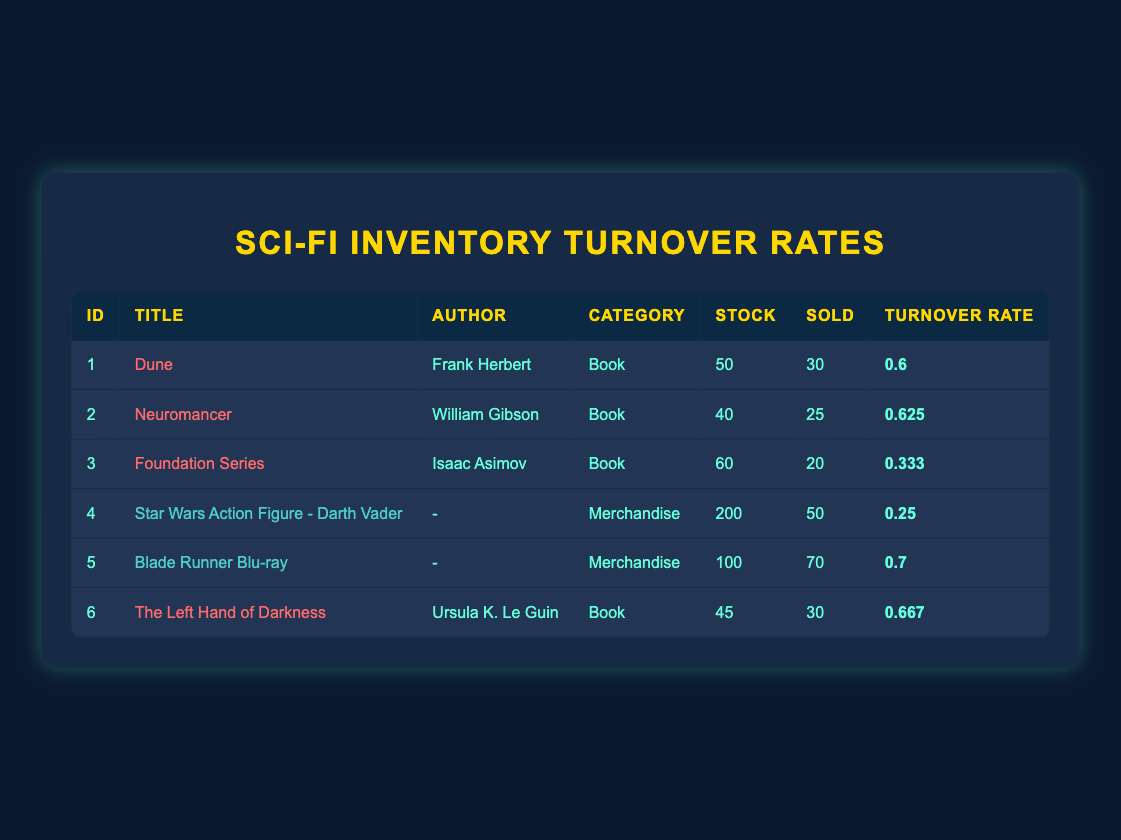What is the title of the book with the highest inventory turnover rate? To find the book with the highest inventory turnover rate, we examine the "Turnover Rate" column for books only (Dune, Neuromancer, Foundation Series, The Left Hand of Darkness). The rates are 0.6, 0.625, 0.333, and 0.667 respectively. The maximum is 0.7 for Blade Runner Blu-ray, but since it is a merchandise item, the highest among books is 0.625 for Neuromancer.
Answer: Neuromancer How many units of the "Star Wars Action Figure - Darth Vader" are currently in stock? The "Stock" column for the item "Star Wars Action Figure - Darth Vader" specifies the units in stock. By looking for that title in the table, we find that it shows 200 units in stock.
Answer: 200 What is the total number of units sold last month for all merchandise? For merchandise, we look at the "Sold" column specifically for items labeled as merchandise. We have two merchandise entries: Darth Vader with 50 units sold and Blade Runner Blu-ray with 70 units sold. Adding these gives us 50 + 70 = 120 units sold last month.
Answer: 120 Is the inventory turnover rate for the "Foundation Series" greater than 0.5? Checking the inventory turnover rate for "Foundation Series," it is reported as 0.333. Since 0.333 is less than 0.5, the statement is false.
Answer: No What is the average inventory turnover rate for all the books listed? The turnover rates for all books are: 0.6 (Dune), 0.625 (Neuromancer), 0.333 (Foundation Series), 0.667 (The Left Hand of Darkness). To find the average, we sum these rates: 0.6 + 0.625 + 0.333 + 0.667 = 2.225. There are 4 books, so we divide by 4: 2.225 / 4 = 0.55625, which we can round to 0.56.
Answer: 0.56 Which item has the lowest inventory turnover rate? The table shows that "Star Wars Action Figure - Darth Vader" has the lowest turnover rate of 0.25 compared to all other items.
Answer: Star Wars Action Figure - Darth Vader 